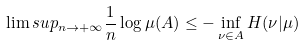Convert formula to latex. <formula><loc_0><loc_0><loc_500><loc_500>\lim s u p _ { n \rightarrow + \infty } \frac { 1 } { n } \log \mu ( A ) \leq - \inf _ { \nu \in A } H ( \nu | \mu )</formula> 